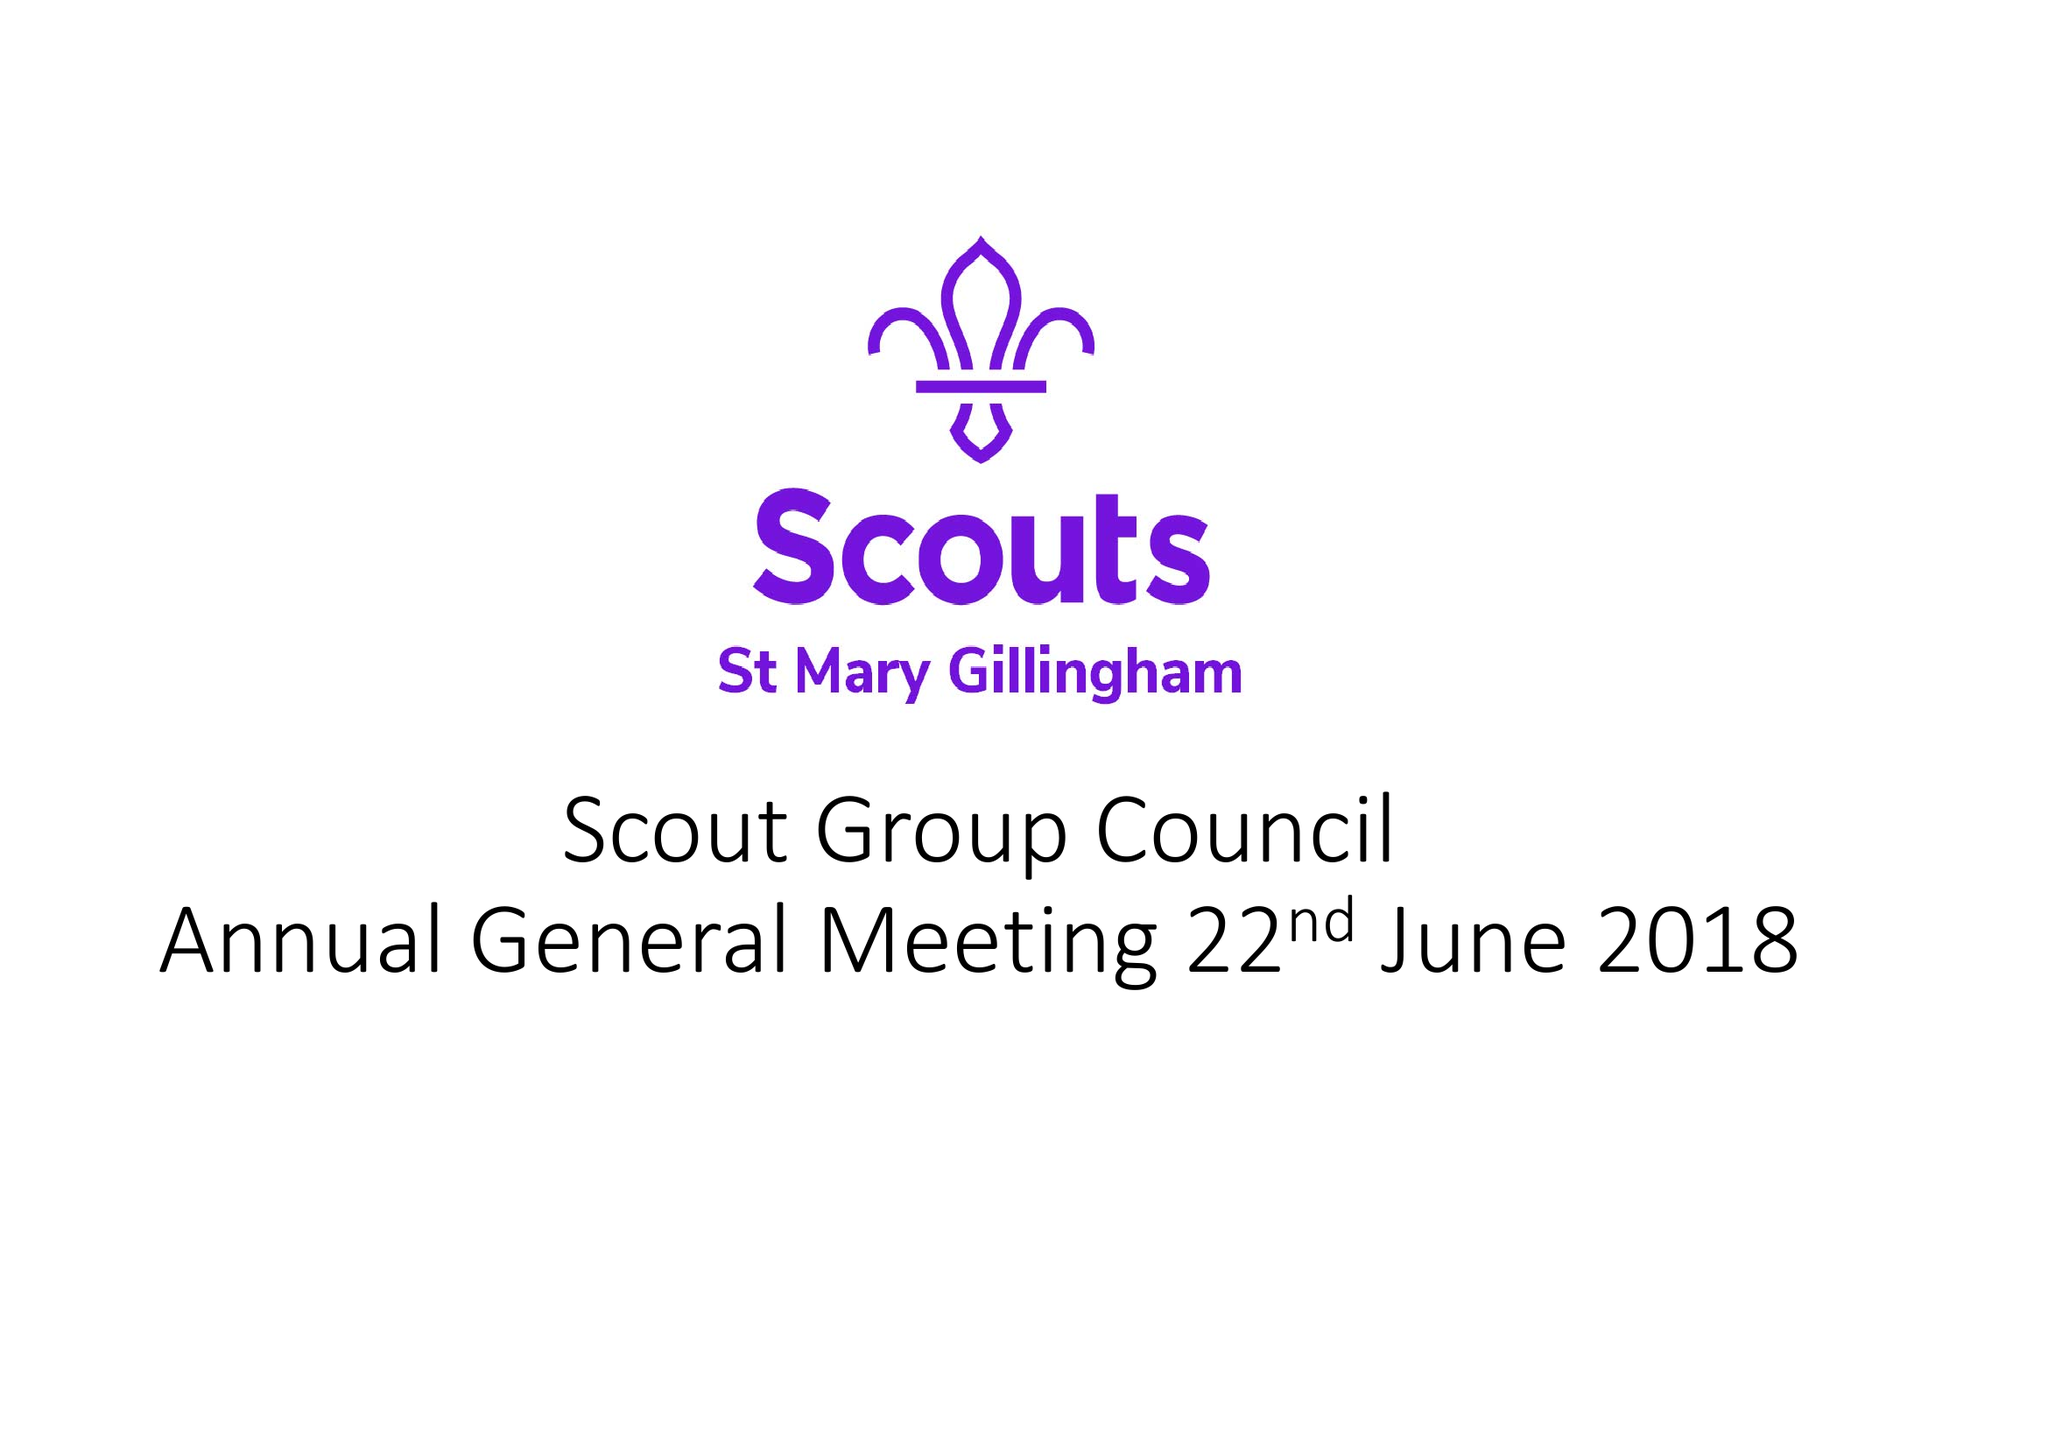What is the value for the report_date?
Answer the question using a single word or phrase. 2018-03-31 